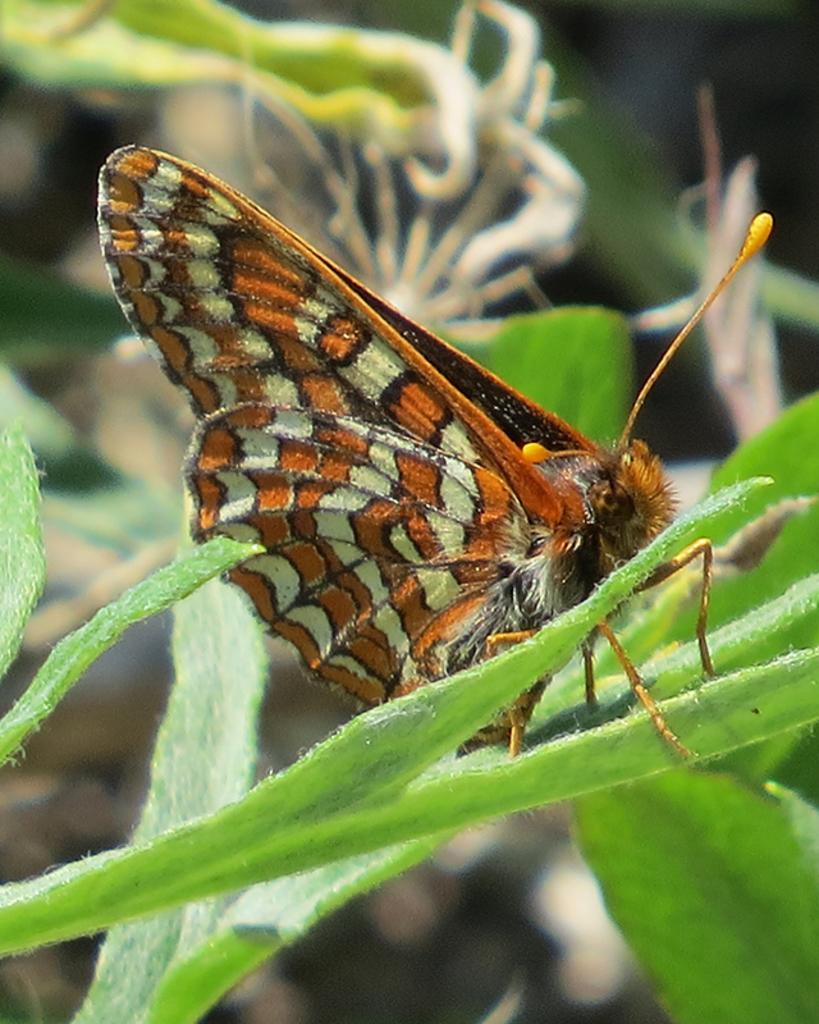What type of creature is present in the image? There is a butterfly in the image. What colors can be seen on the butterfly? The butterfly has white, brown, and black colors. Where is the butterfly located in the image? The butterfly is on a leaf. What color is the leaf? The leaf is green. What type of meat is being served on the boats in the image? There are no boats or meat present in the image; it features a butterfly on a green leaf. 